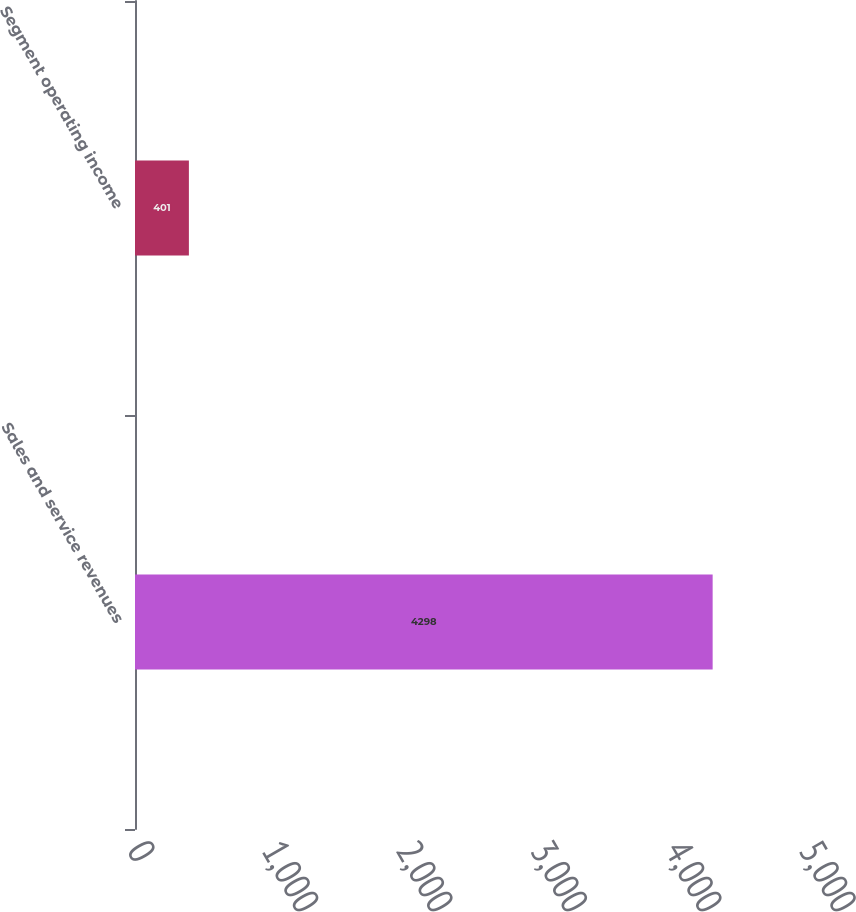Convert chart. <chart><loc_0><loc_0><loc_500><loc_500><bar_chart><fcel>Sales and service revenues<fcel>Segment operating income<nl><fcel>4298<fcel>401<nl></chart> 